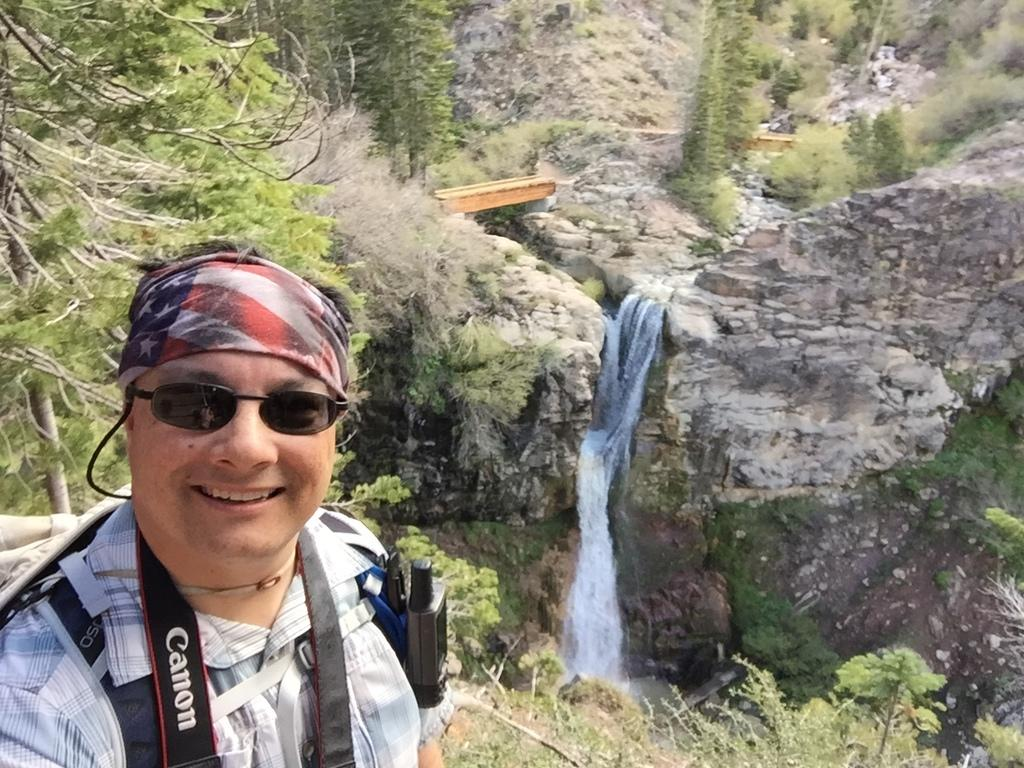What is the person in the image doing? The person is standing in the image. What can be seen on the person's face? The person is wearing glasses. What is the person holding or carrying in the image? The person is carrying a bag. What type of natural scenery is visible in the background of the image? There are trees and a waterfall in the background of the image. What type of pets are visible in the image? There are no pets visible in the image. What type of jeans is the person wearing in the image? The provided facts do not mention the person's jeans, so we cannot determine the type of jeans they are wearing. 